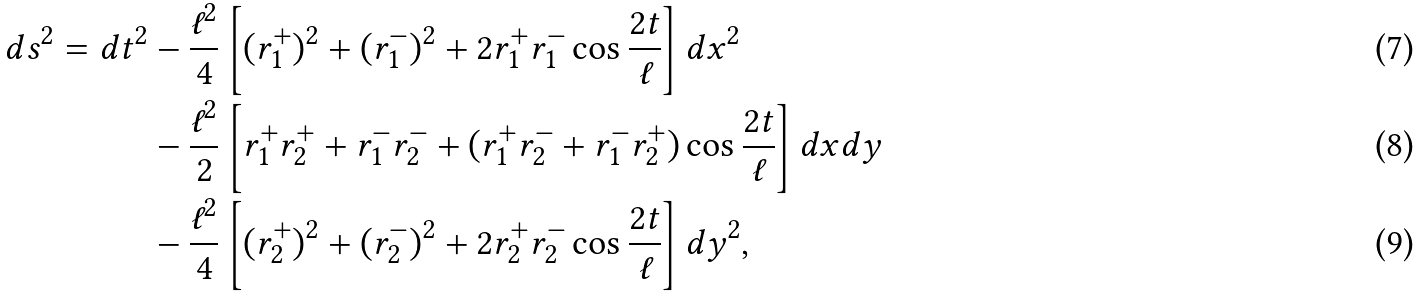Convert formula to latex. <formula><loc_0><loc_0><loc_500><loc_500>d s ^ { 2 } = d t ^ { 2 } & - \frac { \ell ^ { 2 } } { 4 } \left [ ( r _ { 1 } ^ { + } ) ^ { 2 } + ( r _ { 1 } ^ { - } ) ^ { 2 } + 2 r _ { 1 } ^ { + } r _ { 1 } ^ { - } \cos \frac { 2 t } { \ell } \right ] d x ^ { 2 } \\ & - \frac { \ell ^ { 2 } } { 2 } \left [ r _ { 1 } ^ { + } r _ { 2 } ^ { + } + r _ { 1 } ^ { - } r _ { 2 } ^ { - } + ( r _ { 1 } ^ { + } r _ { 2 } ^ { - } + r _ { 1 } ^ { - } r _ { 2 } ^ { + } ) \cos \frac { 2 t } { \ell } \right ] d x d y \\ & - \frac { \ell ^ { 2 } } { 4 } \left [ ( r _ { 2 } ^ { + } ) ^ { 2 } + ( r _ { 2 } ^ { - } ) ^ { 2 } + 2 r _ { 2 } ^ { + } r _ { 2 } ^ { - } \cos \frac { 2 t } { \ell } \right ] d y ^ { 2 } ,</formula> 